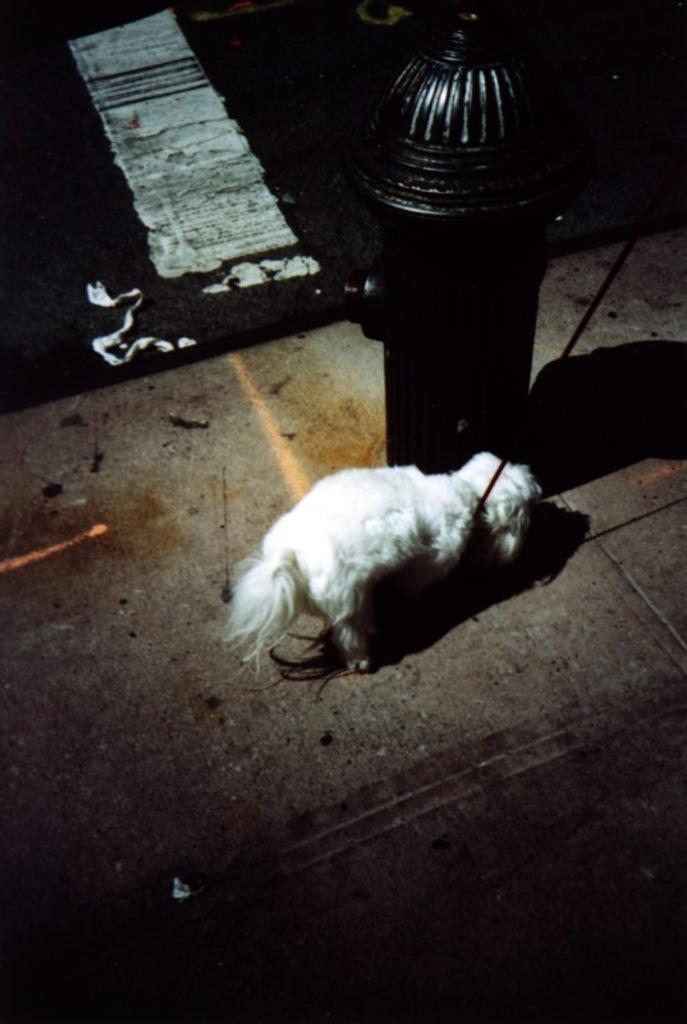What type of animal is in the image? There is a dog in the image. What color is the dog? The dog is white in color. What object is present in the image alongside the dog? There is a fire hydrant in the image. What colors are used in the background of the image? The background of the image is white and black. What type of alarm can be heard going off in the image? There is no alarm present in the image, and therefore no sound can be heard. How many boys are visible in the image? There are no boys present in the image; it features a dog and a fire hydrant. 